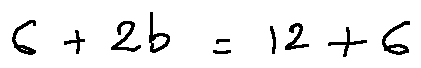Convert formula to latex. <formula><loc_0><loc_0><loc_500><loc_500>6 + 2 b = 1 2 + 6</formula> 